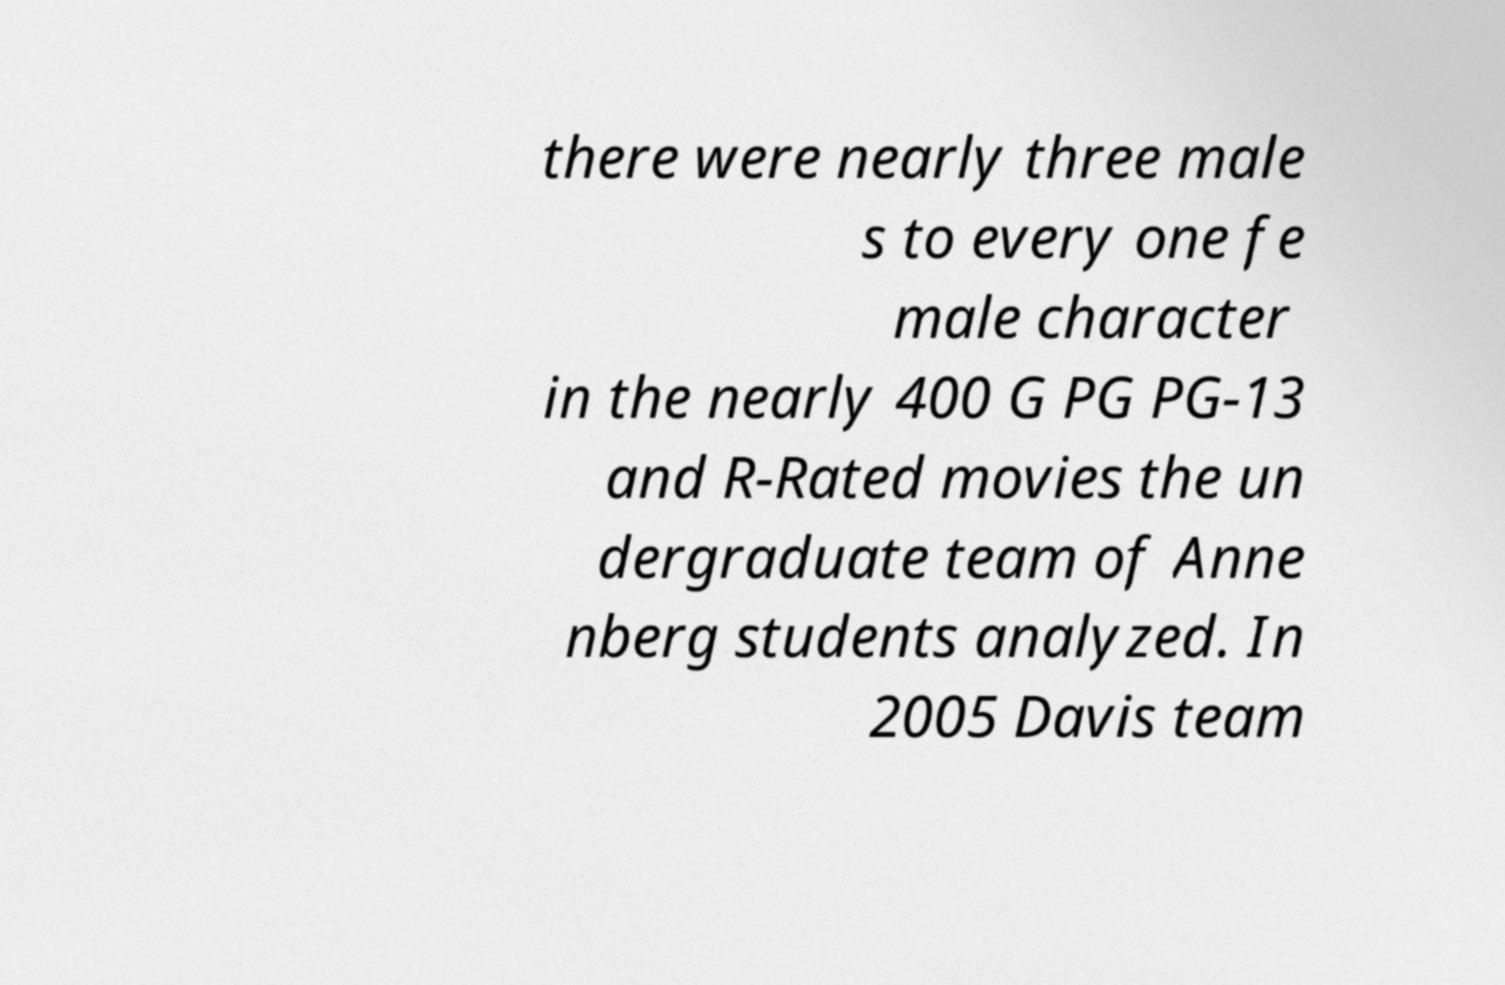For documentation purposes, I need the text within this image transcribed. Could you provide that? there were nearly three male s to every one fe male character in the nearly 400 G PG PG-13 and R-Rated movies the un dergraduate team of Anne nberg students analyzed. In 2005 Davis team 